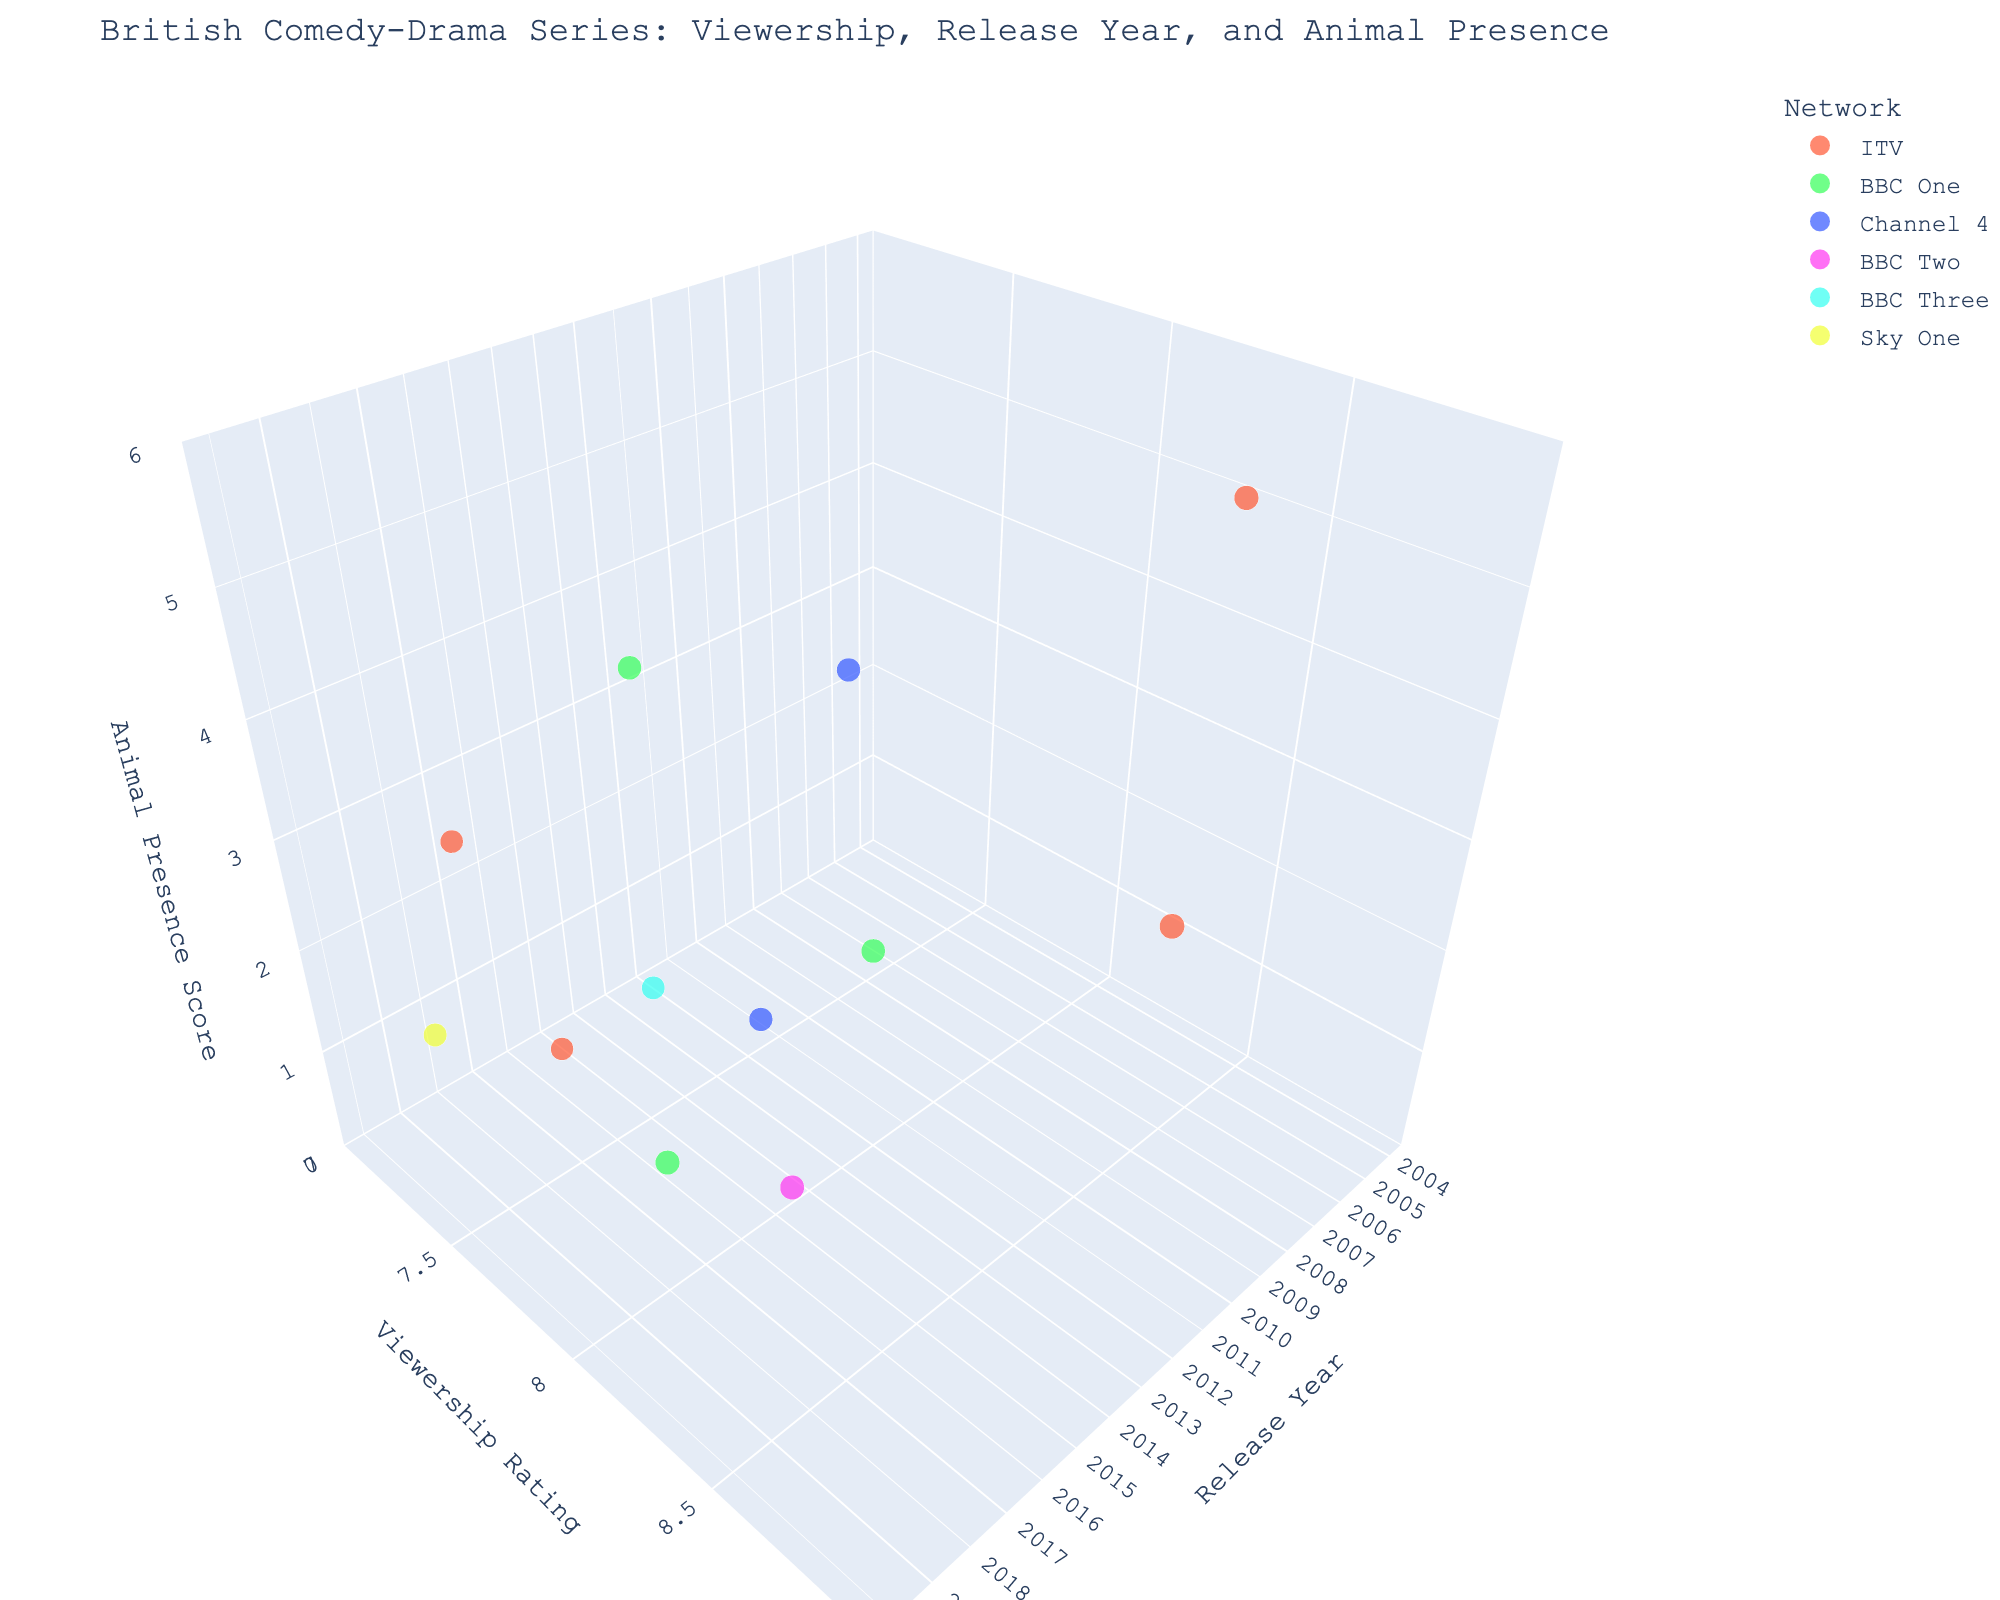What is the title of the figure? The title is usually displayed at the top of the figure in larger or bold text. By observing the figure, we can read the title directly.
Answer: British Comedy-Drama Series: Viewership, Release Year, and Animal Presence Which series has the highest viewership rating? To identify the series with the highest viewership rating, look for the highest point on the y-axis representing viewership ratings. The series title will be visible via hover or by the bubble's hover name.
Answer: Downton Abbey How many series have an "Animal Presence" score of 5? Look for bubbles positioned along the z-axis at the value 5. Count the number of such bubbles in the chart.
Answer: 2 Which network has the most entries in the chart? Review the legend for the networks and count the number of bubbles for each network's designated color. The network with the most bubbles is the answer.
Answer: ITV In which year were the most series released? Examine the x-axis to see the distribution of bubbles along the different years. Identify the year with the densest concentration of bubbles.
Answer: 2014 What is the viewership rating range for ITV shows? To determine the viewership rating range for ITV shows, locate the bubbles colored in ITV's designated color. Identify the minimum and maximum y-axis values these bubbles reach.
Answer: 7.1 to 8.7 Which series had the lowest viewership rating, and what was its "Animal Presence" score? Find the lowest point on the y-axis that represents viewership ratings. Check the corresponding bubble for its series title and then look at its z-axis value for the "Animal Presence" score.
Answer: The Trials of Jimmy Rose, 0 Compare the "Animal Presence" scores of the series released in 2017 and 2018. Which one has a higher score on average? Identify bubbles for the series released in 2017 and 2018 on the x-axis. Find the "Animal Presence" (z-axis) scores for these years and calculate the average for each. Compare the averages.
Answer: 2017: 5, 2018: 3. Average higher in 2017 Which series has similar viewership ratings and animal presence scores as "Doc Martin"? Locate the bubble for "Doc Martin" and observe its coordinates on the y-axis (viewership rating) and z-axis (Animal Presence score). Identify any other bubble with similar y and z values.
Answer: The Durrells What's the average viewership rating for BBC One series in the chart? Identify the bubbles for BBC One series using the legend. Sum their viewership ratings and divide by the number of BBC One series to find the average. BBC One series ratings: 8.0 (Last Tango in Halifax), 7.9 (The Durrells), 8.2 (Gentleman Jack). Sum: 24.1, Number of series: 3, Average: 24.1/3
Answer: 8.03 